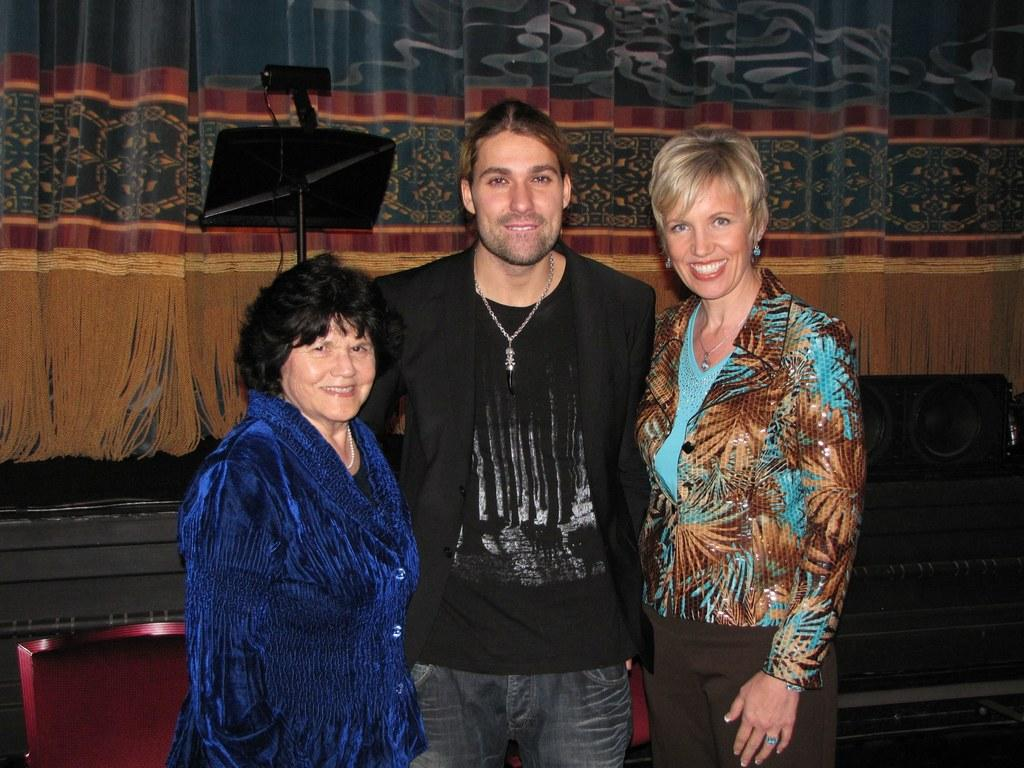How many people are in the image? There are three people in the image: one man and two women. What are the people in the image doing? The man and women are standing and smiling. What can be seen in the background of the image? There is a speaker, a stand, and curtains in the background of the image. What type of nerve can be seen in the image? There is no nerve present in the image. What kind of music is being played by the speaker in the background? The image does not provide any information about the music being played by the speaker. 